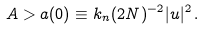Convert formula to latex. <formula><loc_0><loc_0><loc_500><loc_500>A > a ( 0 ) \equiv k _ { n } ( 2 N ) ^ { - 2 } | u | ^ { 2 } \, .</formula> 